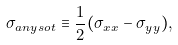Convert formula to latex. <formula><loc_0><loc_0><loc_500><loc_500>\sigma _ { a n y s o t } \equiv \frac { 1 } { 2 } ( \sigma _ { x x } - \sigma _ { y y } ) ,</formula> 